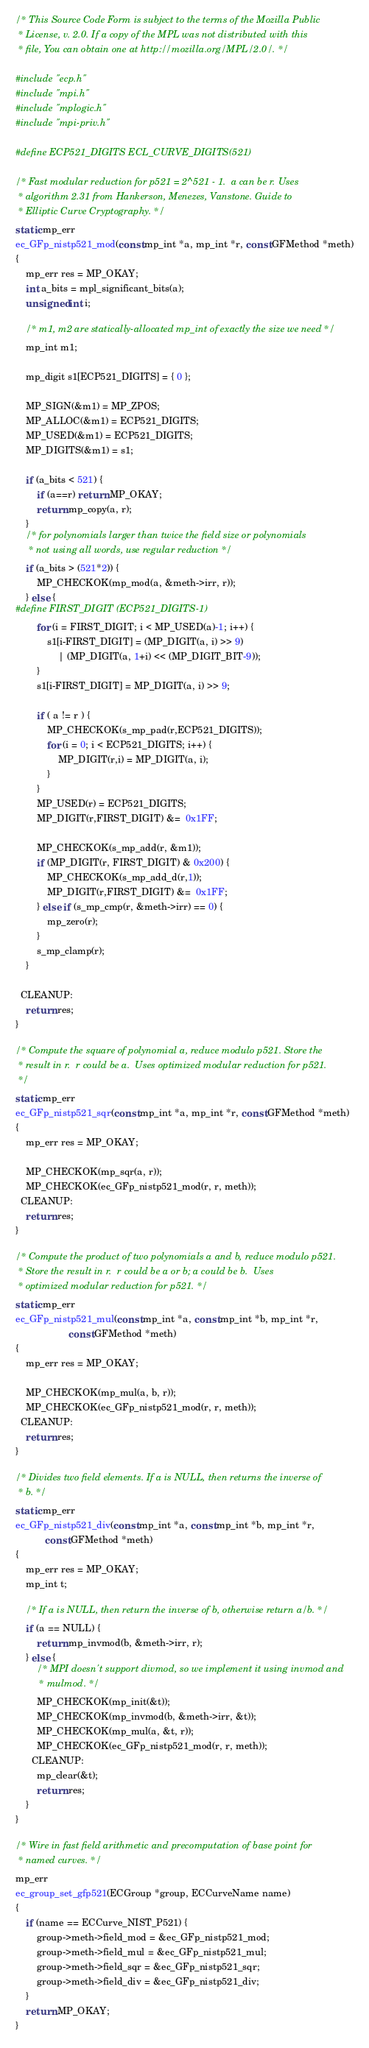<code> <loc_0><loc_0><loc_500><loc_500><_C_>/* This Source Code Form is subject to the terms of the Mozilla Public
 * License, v. 2.0. If a copy of the MPL was not distributed with this
 * file, You can obtain one at http://mozilla.org/MPL/2.0/. */

#include "ecp.h"
#include "mpi.h"
#include "mplogic.h"
#include "mpi-priv.h"

#define ECP521_DIGITS ECL_CURVE_DIGITS(521)

/* Fast modular reduction for p521 = 2^521 - 1.  a can be r. Uses
 * algorithm 2.31 from Hankerson, Menezes, Vanstone. Guide to 
 * Elliptic Curve Cryptography. */
static mp_err
ec_GFp_nistp521_mod(const mp_int *a, mp_int *r, const GFMethod *meth)
{
	mp_err res = MP_OKAY;
	int a_bits = mpl_significant_bits(a);
	unsigned int i;

	/* m1, m2 are statically-allocated mp_int of exactly the size we need */
	mp_int m1;

	mp_digit s1[ECP521_DIGITS] = { 0 };

	MP_SIGN(&m1) = MP_ZPOS;
	MP_ALLOC(&m1) = ECP521_DIGITS;
	MP_USED(&m1) = ECP521_DIGITS;
	MP_DIGITS(&m1) = s1;

	if (a_bits < 521) {
		if (a==r) return MP_OKAY;
		return mp_copy(a, r);
	}
	/* for polynomials larger than twice the field size or polynomials 
	 * not using all words, use regular reduction */
	if (a_bits > (521*2)) {
		MP_CHECKOK(mp_mod(a, &meth->irr, r));
	} else {
#define FIRST_DIGIT (ECP521_DIGITS-1)
		for (i = FIRST_DIGIT; i < MP_USED(a)-1; i++) {
			s1[i-FIRST_DIGIT] = (MP_DIGIT(a, i) >> 9) 
				| (MP_DIGIT(a, 1+i) << (MP_DIGIT_BIT-9));
		}
		s1[i-FIRST_DIGIT] = MP_DIGIT(a, i) >> 9;

		if ( a != r ) {
			MP_CHECKOK(s_mp_pad(r,ECP521_DIGITS));
			for (i = 0; i < ECP521_DIGITS; i++) {
				MP_DIGIT(r,i) = MP_DIGIT(a, i);
			}
		}
		MP_USED(r) = ECP521_DIGITS;
		MP_DIGIT(r,FIRST_DIGIT) &=  0x1FF;

		MP_CHECKOK(s_mp_add(r, &m1));
		if (MP_DIGIT(r, FIRST_DIGIT) & 0x200) {
			MP_CHECKOK(s_mp_add_d(r,1));
			MP_DIGIT(r,FIRST_DIGIT) &=  0x1FF;
		} else if (s_mp_cmp(r, &meth->irr) == 0) {
			mp_zero(r);
		}
		s_mp_clamp(r);
	}

  CLEANUP:
	return res;
}

/* Compute the square of polynomial a, reduce modulo p521. Store the
 * result in r.  r could be a.  Uses optimized modular reduction for p521. 
 */
static mp_err
ec_GFp_nistp521_sqr(const mp_int *a, mp_int *r, const GFMethod *meth)
{
	mp_err res = MP_OKAY;

	MP_CHECKOK(mp_sqr(a, r));
	MP_CHECKOK(ec_GFp_nistp521_mod(r, r, meth));
  CLEANUP:
	return res;
}

/* Compute the product of two polynomials a and b, reduce modulo p521.
 * Store the result in r.  r could be a or b; a could be b.  Uses
 * optimized modular reduction for p521. */
static mp_err
ec_GFp_nistp521_mul(const mp_int *a, const mp_int *b, mp_int *r,
					const GFMethod *meth)
{
	mp_err res = MP_OKAY;

	MP_CHECKOK(mp_mul(a, b, r));
	MP_CHECKOK(ec_GFp_nistp521_mod(r, r, meth));
  CLEANUP:
	return res;
}

/* Divides two field elements. If a is NULL, then returns the inverse of
 * b. */
static mp_err
ec_GFp_nistp521_div(const mp_int *a, const mp_int *b, mp_int *r,
		   const GFMethod *meth)
{
	mp_err res = MP_OKAY;
	mp_int t;

	/* If a is NULL, then return the inverse of b, otherwise return a/b. */
	if (a == NULL) {
		return mp_invmod(b, &meth->irr, r);
	} else {
		/* MPI doesn't support divmod, so we implement it using invmod and 
		 * mulmod. */
		MP_CHECKOK(mp_init(&t));
		MP_CHECKOK(mp_invmod(b, &meth->irr, &t));
		MP_CHECKOK(mp_mul(a, &t, r));
		MP_CHECKOK(ec_GFp_nistp521_mod(r, r, meth));
	  CLEANUP:
		mp_clear(&t);
		return res;
	}
}

/* Wire in fast field arithmetic and precomputation of base point for
 * named curves. */
mp_err
ec_group_set_gfp521(ECGroup *group, ECCurveName name)
{
	if (name == ECCurve_NIST_P521) {
		group->meth->field_mod = &ec_GFp_nistp521_mod;
		group->meth->field_mul = &ec_GFp_nistp521_mul;
		group->meth->field_sqr = &ec_GFp_nistp521_sqr;
		group->meth->field_div = &ec_GFp_nistp521_div;
	}
	return MP_OKAY;
}
</code> 